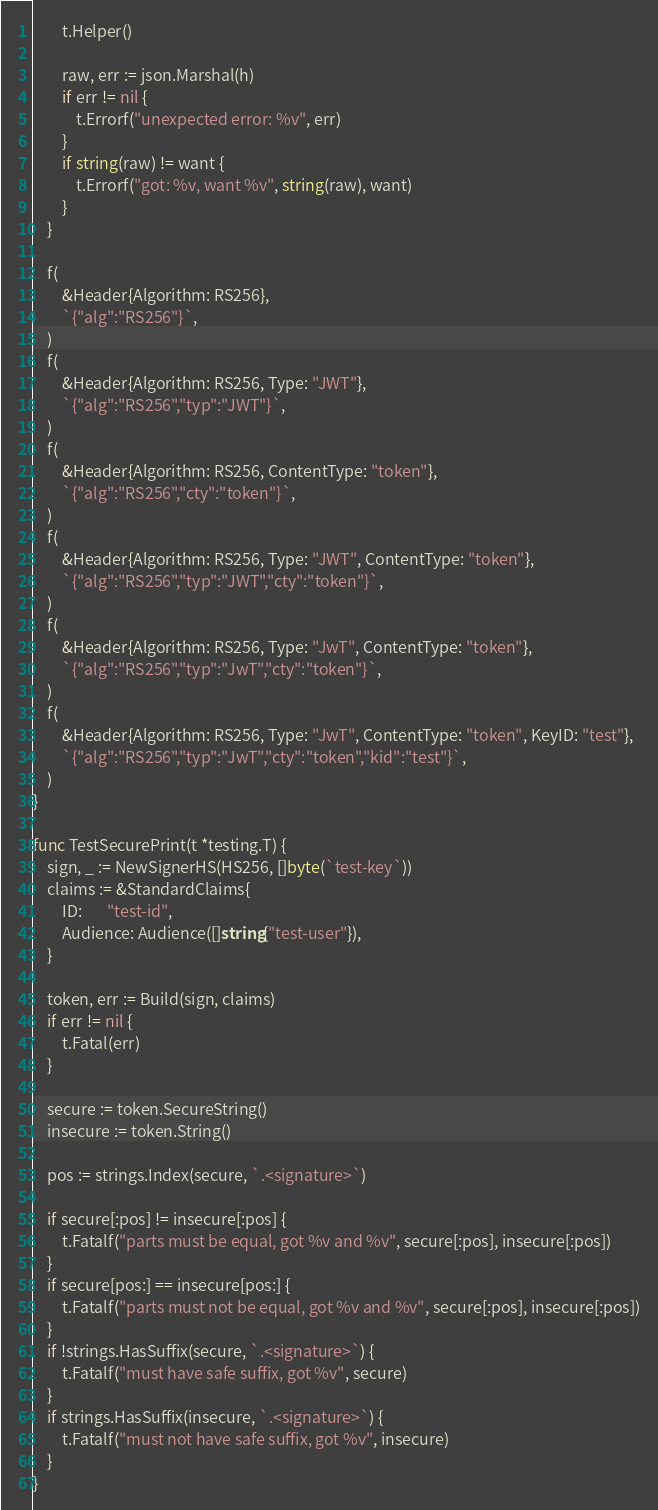<code> <loc_0><loc_0><loc_500><loc_500><_Go_>		t.Helper()

		raw, err := json.Marshal(h)
		if err != nil {
			t.Errorf("unexpected error: %v", err)
		}
		if string(raw) != want {
			t.Errorf("got: %v, want %v", string(raw), want)
		}
	}

	f(
		&Header{Algorithm: RS256},
		`{"alg":"RS256"}`,
	)
	f(
		&Header{Algorithm: RS256, Type: "JWT"},
		`{"alg":"RS256","typ":"JWT"}`,
	)
	f(
		&Header{Algorithm: RS256, ContentType: "token"},
		`{"alg":"RS256","cty":"token"}`,
	)
	f(
		&Header{Algorithm: RS256, Type: "JWT", ContentType: "token"},
		`{"alg":"RS256","typ":"JWT","cty":"token"}`,
	)
	f(
		&Header{Algorithm: RS256, Type: "JwT", ContentType: "token"},
		`{"alg":"RS256","typ":"JwT","cty":"token"}`,
	)
	f(
		&Header{Algorithm: RS256, Type: "JwT", ContentType: "token", KeyID: "test"},
		`{"alg":"RS256","typ":"JwT","cty":"token","kid":"test"}`,
	)
}

func TestSecurePrint(t *testing.T) {
	sign, _ := NewSignerHS(HS256, []byte(`test-key`))
	claims := &StandardClaims{
		ID:       "test-id",
		Audience: Audience([]string{"test-user"}),
	}

	token, err := Build(sign, claims)
	if err != nil {
		t.Fatal(err)
	}

	secure := token.SecureString()
	insecure := token.String()

	pos := strings.Index(secure, `.<signature>`)

	if secure[:pos] != insecure[:pos] {
		t.Fatalf("parts must be equal, got %v and %v", secure[:pos], insecure[:pos])
	}
	if secure[pos:] == insecure[pos:] {
		t.Fatalf("parts must not be equal, got %v and %v", secure[:pos], insecure[:pos])
	}
	if !strings.HasSuffix(secure, `.<signature>`) {
		t.Fatalf("must have safe suffix, got %v", secure)
	}
	if strings.HasSuffix(insecure, `.<signature>`) {
		t.Fatalf("must not have safe suffix, got %v", insecure)
	}
}
</code> 